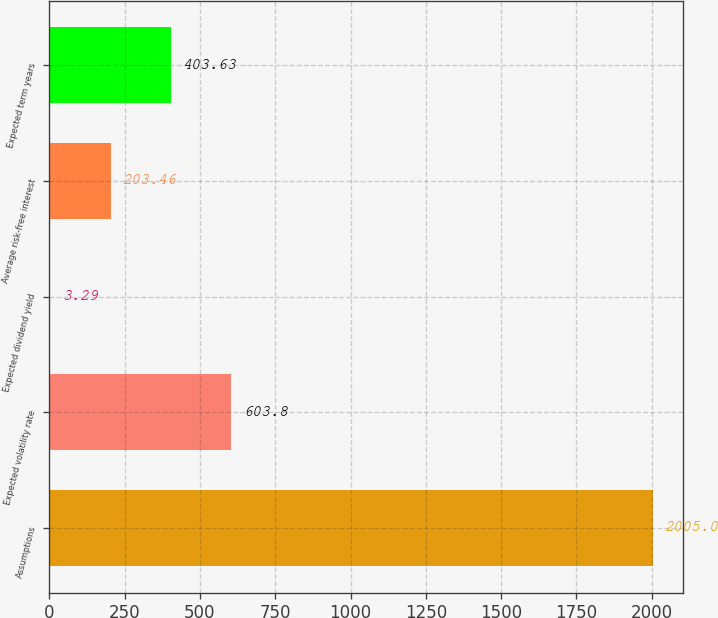Convert chart. <chart><loc_0><loc_0><loc_500><loc_500><bar_chart><fcel>Assumptions<fcel>Expected volatility rate<fcel>Expected dividend yield<fcel>Average risk-free interest<fcel>Expected term years<nl><fcel>2005<fcel>603.8<fcel>3.29<fcel>203.46<fcel>403.63<nl></chart> 